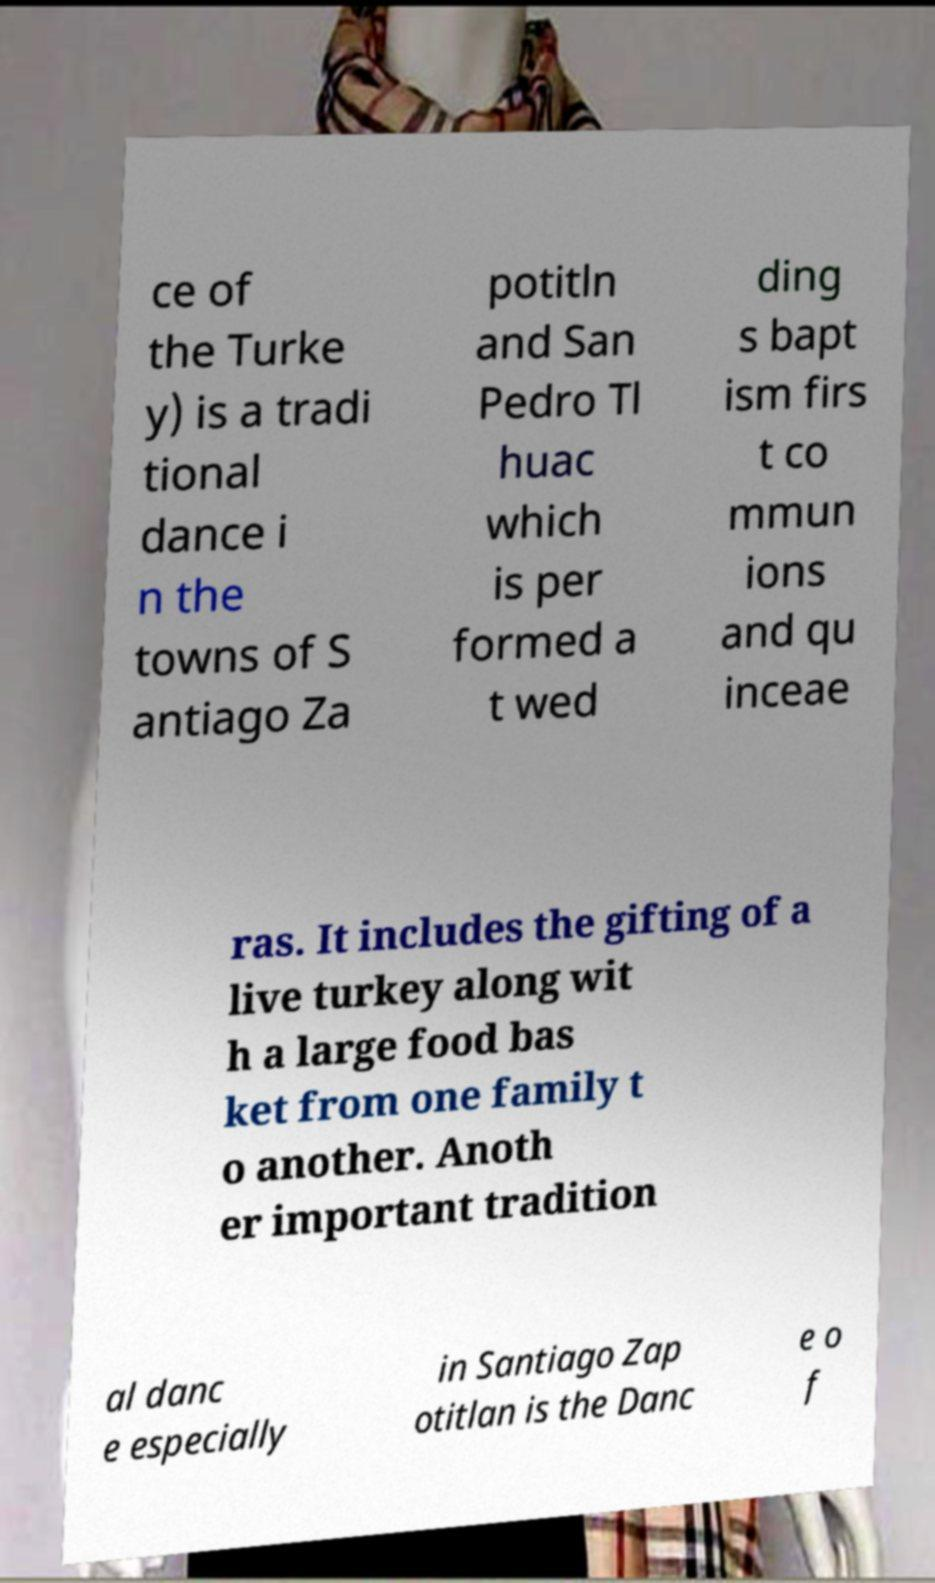Could you assist in decoding the text presented in this image and type it out clearly? ce of the Turke y) is a tradi tional dance i n the towns of S antiago Za potitln and San Pedro Tl huac which is per formed a t wed ding s bapt ism firs t co mmun ions and qu inceae ras. It includes the gifting of a live turkey along wit h a large food bas ket from one family t o another. Anoth er important tradition al danc e especially in Santiago Zap otitlan is the Danc e o f 